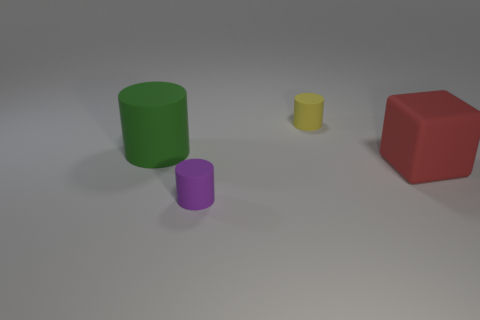Add 2 small yellow matte cylinders. How many objects exist? 6 Subtract all cylinders. How many objects are left? 1 Subtract 0 brown cylinders. How many objects are left? 4 Subtract all tiny blue balls. Subtract all small cylinders. How many objects are left? 2 Add 4 purple objects. How many purple objects are left? 5 Add 1 rubber cylinders. How many rubber cylinders exist? 4 